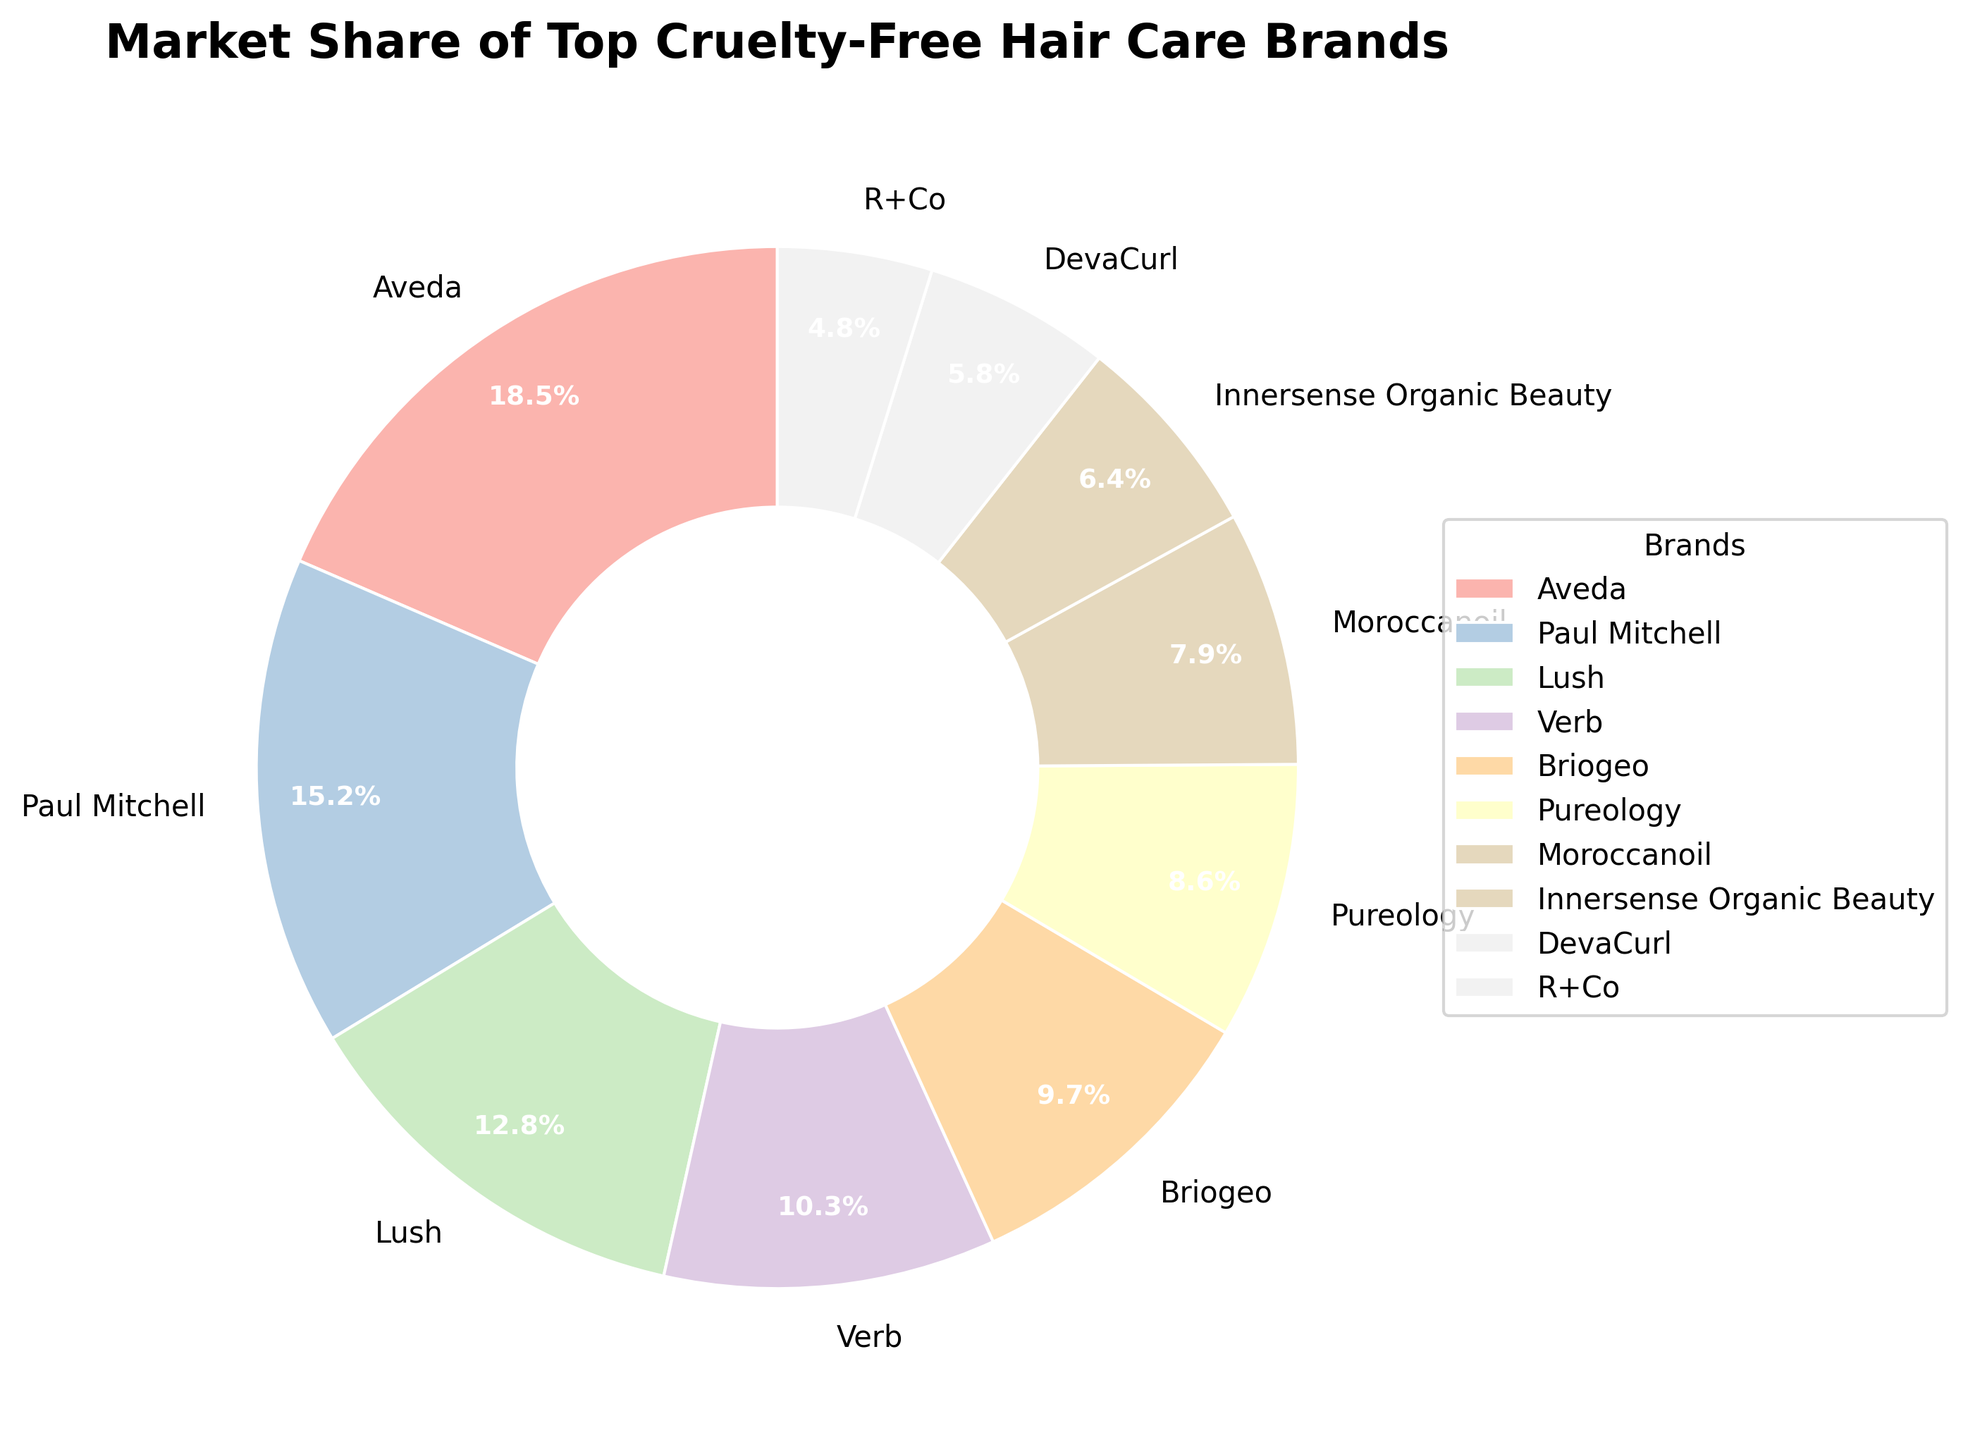What's the combined market share of Aveda and Paul Mitchell? Aveda has a market share of 18.5% and Paul Mitchell has 15.2%. Adding these two together gives 18.5% + 15.2% = 33.7%.
Answer: 33.7% Which brand has a larger market share: Lush or Verb? Lush has a market share of 12.8% and Verb has a market share of 10.3%. Since 12.8% is greater than 10.3%, Lush has a larger market share than Verb.
Answer: Lush What is the difference in market share between the top brand (Aveda) and the second top brand (Paul Mitchell)? The market share of Aveda is 18.5% and the market share of Paul Mitchell is 15.2%. The difference is 18.5% - 15.2% = 3.3%.
Answer: 3.3% What's the combined market share of the three brands with the smallest market shares? The three brands with the smallest market shares are R+Co (4.8%), DevaCurl (5.8%), and Innersense Organic Beauty (6.4%). Adding these together gives 4.8% + 5.8% + 6.4% = 17.0%.
Answer: 17.0% Which brand has approximately one-tenth of the market share of Aveda? Aveda has a market share of 18.5%. One-tenth of 18.5% is approximately 1.85%. Evaluating the market shares, R+Co has 4.8%, which is the closest but not exact one-tenth. None of the brands have exactly one-tenth of Aveda's market share.
Answer: None What's the total market share of all brands with more than 10% market share? The brands with market shares more than 10% are Aveda (18.5%), Paul Mitchell (15.2%), and Lush (12.8%). Adding these together gives 18.5% + 15.2% + 12.8% = 46.5%.
Answer: 46.5% Between Moroccanoil and Pureology, which brand holds a larger market share, and by how much? Moroccanoil has a market share of 7.9% and Pureology has 8.6%. Pureology has a larger market share than Moroccanoil by 8.6% - 7.9% = 0.7%.
Answer: Pureology, 0.7% What percentage of the market do the brands Briogeo and Pureology share together? Briogeo has a market share of 9.7% and Pureology has 8.6%. Adding these together gives 9.7% + 8.6% = 18.3%.
Answer: 18.3% If the market share of Verb increased by 5%, what would its new market share be, and would it surpass Lush? Verb's original market share is 10.3%. If it increased by 5%, the new market share would be 10.3% + 5% = 15.3%. Lush has a market share of 12.8%, so Verb's new market share (15.3%) would surpass Lush's market share.
Answer: 15.3%, yes 